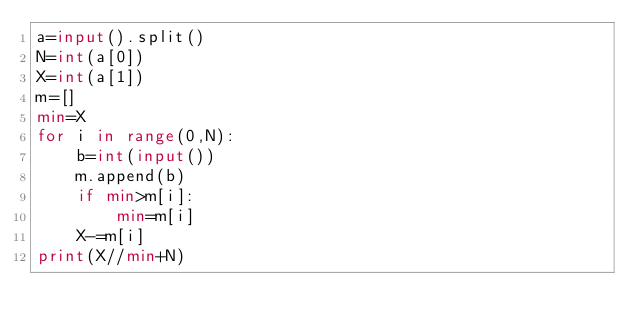<code> <loc_0><loc_0><loc_500><loc_500><_Python_>a=input().split()
N=int(a[0])
X=int(a[1])
m=[]
min=X
for i in range(0,N):
    b=int(input())
    m.append(b)
    if min>m[i]:
        min=m[i]
    X-=m[i]
print(X//min+N)</code> 